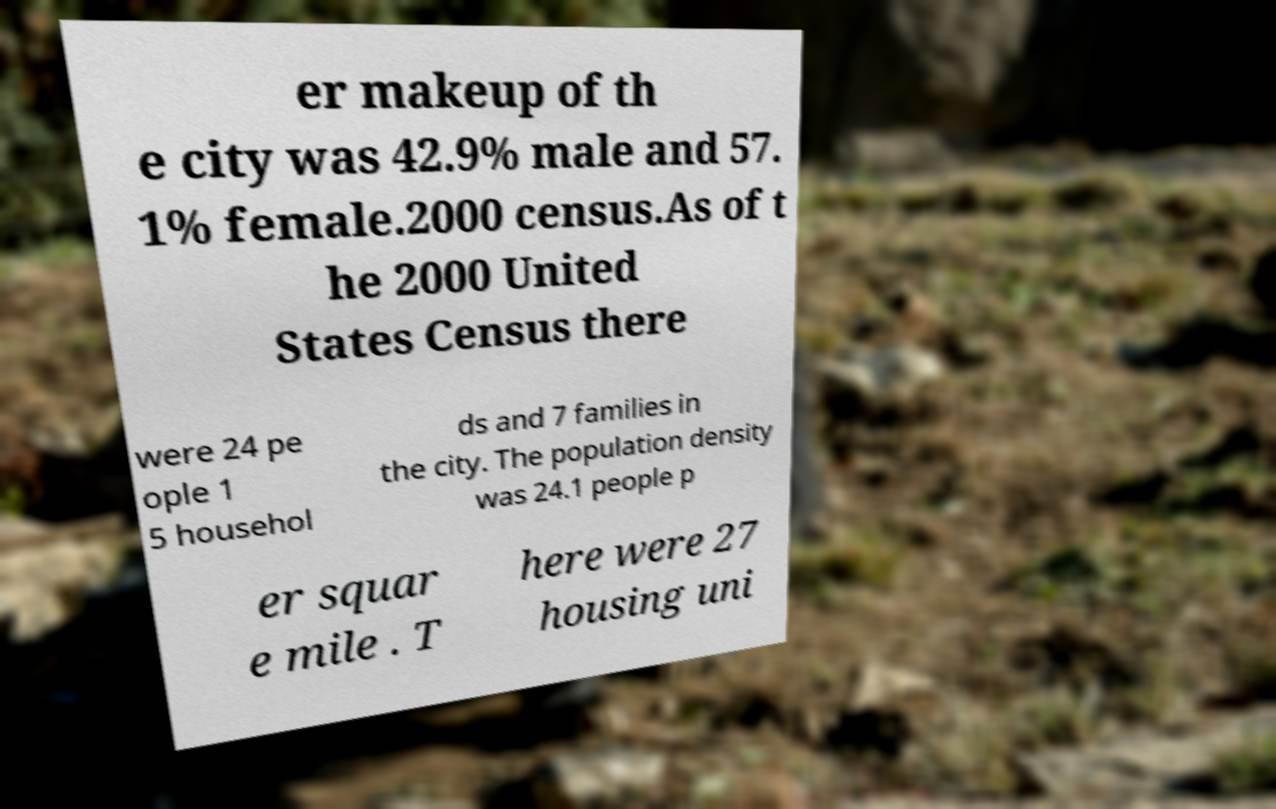I need the written content from this picture converted into text. Can you do that? er makeup of th e city was 42.9% male and 57. 1% female.2000 census.As of t he 2000 United States Census there were 24 pe ople 1 5 househol ds and 7 families in the city. The population density was 24.1 people p er squar e mile . T here were 27 housing uni 